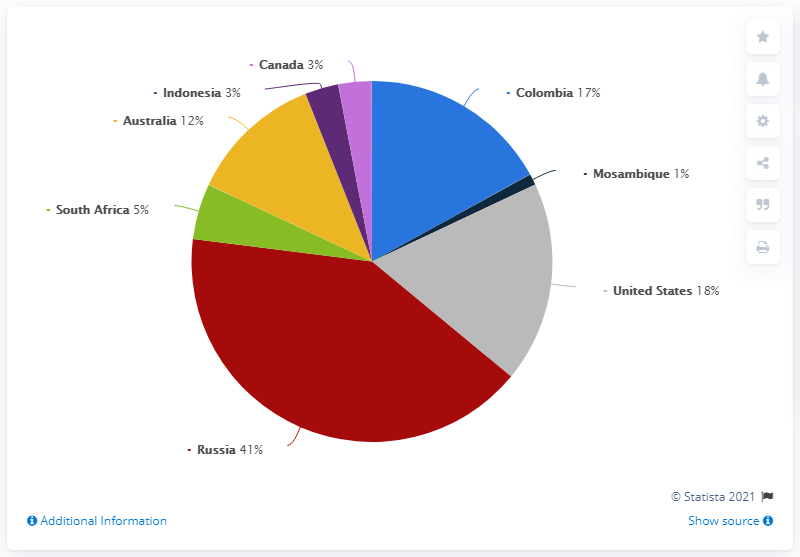Mention a couple of crucial points in this snapshot. In 2017, the European Union countries imported the largest share of hard coal from Russia, accounting for a significant percentage of their total hard coal imports that year. Mozambique has the lowest volume among all countries. According to the given information, Russia, the US, and Colombia make up approximately 76% of the global net sinking area. 